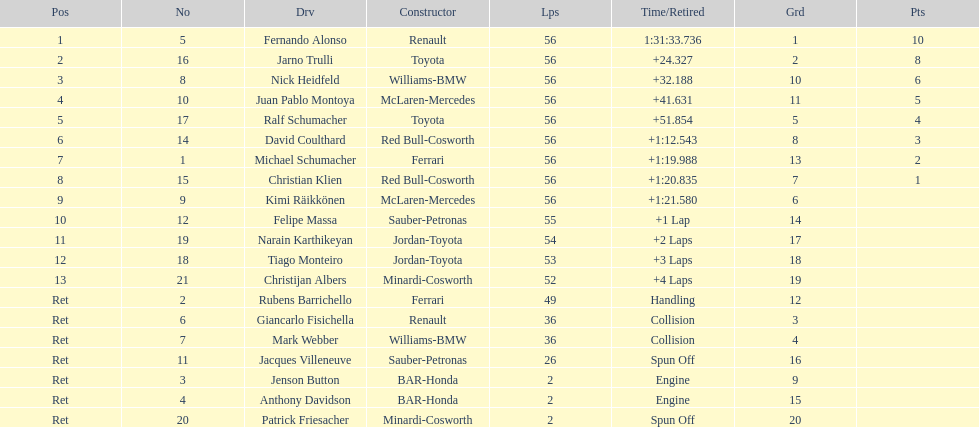What was the aggregate number of laps concluded by the 1st rank winner? 56. 